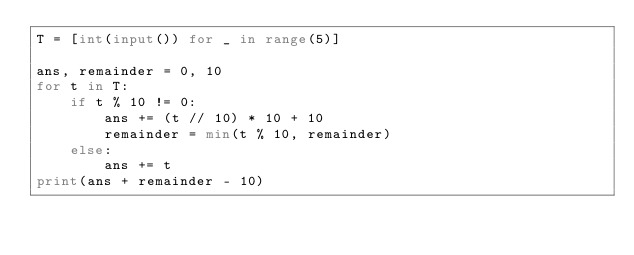<code> <loc_0><loc_0><loc_500><loc_500><_Python_>T = [int(input()) for _ in range(5)]

ans, remainder = 0, 10
for t in T:
    if t % 10 != 0:
        ans += (t // 10) * 10 + 10
        remainder = min(t % 10, remainder)
    else:
        ans += t
print(ans + remainder - 10)
</code> 